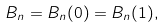<formula> <loc_0><loc_0><loc_500><loc_500>B _ { n } = B _ { n } ( 0 ) = B _ { n } ( 1 ) ,</formula> 